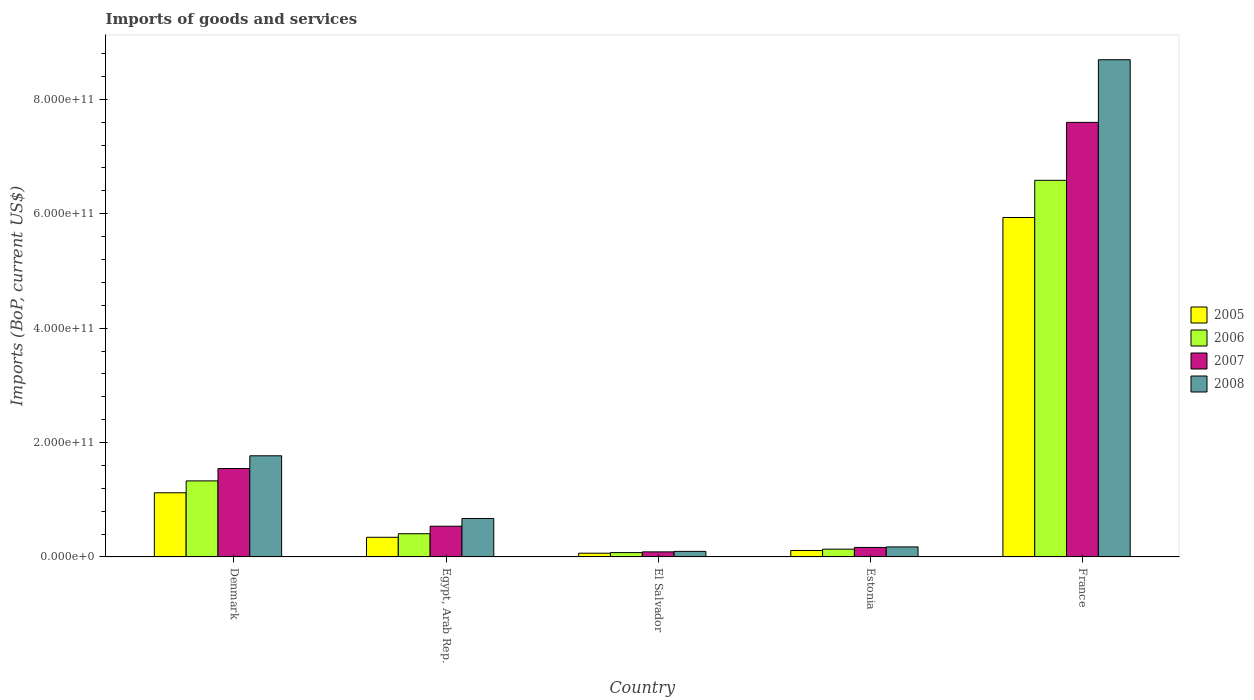How many groups of bars are there?
Keep it short and to the point. 5. Are the number of bars per tick equal to the number of legend labels?
Offer a very short reply. Yes. How many bars are there on the 4th tick from the left?
Provide a succinct answer. 4. How many bars are there on the 2nd tick from the right?
Your answer should be compact. 4. What is the label of the 3rd group of bars from the left?
Keep it short and to the point. El Salvador. In how many cases, is the number of bars for a given country not equal to the number of legend labels?
Offer a very short reply. 0. What is the amount spent on imports in 2005 in France?
Keep it short and to the point. 5.93e+11. Across all countries, what is the maximum amount spent on imports in 2006?
Provide a succinct answer. 6.58e+11. Across all countries, what is the minimum amount spent on imports in 2005?
Offer a terse response. 6.51e+09. In which country was the amount spent on imports in 2006 minimum?
Your answer should be very brief. El Salvador. What is the total amount spent on imports in 2007 in the graph?
Offer a terse response. 9.93e+11. What is the difference between the amount spent on imports in 2005 in Denmark and that in El Salvador?
Make the answer very short. 1.06e+11. What is the difference between the amount spent on imports in 2005 in El Salvador and the amount spent on imports in 2008 in Denmark?
Make the answer very short. -1.70e+11. What is the average amount spent on imports in 2005 per country?
Make the answer very short. 1.52e+11. What is the difference between the amount spent on imports of/in 2005 and amount spent on imports of/in 2006 in France?
Give a very brief answer. -6.50e+1. In how many countries, is the amount spent on imports in 2007 greater than 800000000000 US$?
Your answer should be compact. 0. What is the ratio of the amount spent on imports in 2007 in Denmark to that in France?
Offer a terse response. 0.2. Is the amount spent on imports in 2007 in Estonia less than that in France?
Ensure brevity in your answer.  Yes. Is the difference between the amount spent on imports in 2005 in Egypt, Arab Rep. and Estonia greater than the difference between the amount spent on imports in 2006 in Egypt, Arab Rep. and Estonia?
Offer a very short reply. No. What is the difference between the highest and the second highest amount spent on imports in 2006?
Your answer should be very brief. 5.26e+11. What is the difference between the highest and the lowest amount spent on imports in 2007?
Your response must be concise. 7.51e+11. In how many countries, is the amount spent on imports in 2006 greater than the average amount spent on imports in 2006 taken over all countries?
Provide a short and direct response. 1. What does the 4th bar from the left in France represents?
Offer a very short reply. 2008. What does the 3rd bar from the right in Estonia represents?
Keep it short and to the point. 2006. How many bars are there?
Your response must be concise. 20. Are all the bars in the graph horizontal?
Your response must be concise. No. What is the difference between two consecutive major ticks on the Y-axis?
Keep it short and to the point. 2.00e+11. Where does the legend appear in the graph?
Offer a very short reply. Center right. What is the title of the graph?
Give a very brief answer. Imports of goods and services. Does "2009" appear as one of the legend labels in the graph?
Keep it short and to the point. No. What is the label or title of the X-axis?
Your answer should be very brief. Country. What is the label or title of the Y-axis?
Offer a terse response. Imports (BoP, current US$). What is the Imports (BoP, current US$) in 2005 in Denmark?
Ensure brevity in your answer.  1.12e+11. What is the Imports (BoP, current US$) of 2006 in Denmark?
Your answer should be compact. 1.33e+11. What is the Imports (BoP, current US$) in 2007 in Denmark?
Provide a succinct answer. 1.55e+11. What is the Imports (BoP, current US$) in 2008 in Denmark?
Provide a short and direct response. 1.77e+11. What is the Imports (BoP, current US$) of 2005 in Egypt, Arab Rep.?
Offer a very short reply. 3.43e+1. What is the Imports (BoP, current US$) of 2006 in Egypt, Arab Rep.?
Offer a terse response. 4.06e+1. What is the Imports (BoP, current US$) of 2007 in Egypt, Arab Rep.?
Your response must be concise. 5.37e+1. What is the Imports (BoP, current US$) of 2008 in Egypt, Arab Rep.?
Give a very brief answer. 6.72e+1. What is the Imports (BoP, current US$) in 2005 in El Salvador?
Offer a terse response. 6.51e+09. What is the Imports (BoP, current US$) in 2006 in El Salvador?
Your response must be concise. 7.57e+09. What is the Imports (BoP, current US$) of 2007 in El Salvador?
Make the answer very short. 8.86e+09. What is the Imports (BoP, current US$) in 2008 in El Salvador?
Make the answer very short. 9.70e+09. What is the Imports (BoP, current US$) in 2005 in Estonia?
Offer a terse response. 1.12e+1. What is the Imports (BoP, current US$) in 2006 in Estonia?
Give a very brief answer. 1.36e+1. What is the Imports (BoP, current US$) in 2007 in Estonia?
Provide a short and direct response. 1.66e+1. What is the Imports (BoP, current US$) of 2008 in Estonia?
Ensure brevity in your answer.  1.75e+1. What is the Imports (BoP, current US$) in 2005 in France?
Your answer should be very brief. 5.93e+11. What is the Imports (BoP, current US$) in 2006 in France?
Your response must be concise. 6.58e+11. What is the Imports (BoP, current US$) in 2007 in France?
Your answer should be compact. 7.60e+11. What is the Imports (BoP, current US$) in 2008 in France?
Give a very brief answer. 8.69e+11. Across all countries, what is the maximum Imports (BoP, current US$) of 2005?
Your answer should be compact. 5.93e+11. Across all countries, what is the maximum Imports (BoP, current US$) of 2006?
Offer a terse response. 6.58e+11. Across all countries, what is the maximum Imports (BoP, current US$) in 2007?
Offer a very short reply. 7.60e+11. Across all countries, what is the maximum Imports (BoP, current US$) of 2008?
Offer a very short reply. 8.69e+11. Across all countries, what is the minimum Imports (BoP, current US$) of 2005?
Provide a short and direct response. 6.51e+09. Across all countries, what is the minimum Imports (BoP, current US$) in 2006?
Your answer should be very brief. 7.57e+09. Across all countries, what is the minimum Imports (BoP, current US$) of 2007?
Keep it short and to the point. 8.86e+09. Across all countries, what is the minimum Imports (BoP, current US$) in 2008?
Keep it short and to the point. 9.70e+09. What is the total Imports (BoP, current US$) of 2005 in the graph?
Make the answer very short. 7.58e+11. What is the total Imports (BoP, current US$) of 2006 in the graph?
Your answer should be very brief. 8.53e+11. What is the total Imports (BoP, current US$) of 2007 in the graph?
Provide a short and direct response. 9.93e+11. What is the total Imports (BoP, current US$) in 2008 in the graph?
Offer a terse response. 1.14e+12. What is the difference between the Imports (BoP, current US$) of 2005 in Denmark and that in Egypt, Arab Rep.?
Your response must be concise. 7.78e+1. What is the difference between the Imports (BoP, current US$) in 2006 in Denmark and that in Egypt, Arab Rep.?
Keep it short and to the point. 9.24e+1. What is the difference between the Imports (BoP, current US$) of 2007 in Denmark and that in Egypt, Arab Rep.?
Your answer should be very brief. 1.01e+11. What is the difference between the Imports (BoP, current US$) in 2008 in Denmark and that in Egypt, Arab Rep.?
Your answer should be compact. 1.10e+11. What is the difference between the Imports (BoP, current US$) in 2005 in Denmark and that in El Salvador?
Your response must be concise. 1.06e+11. What is the difference between the Imports (BoP, current US$) of 2006 in Denmark and that in El Salvador?
Provide a succinct answer. 1.25e+11. What is the difference between the Imports (BoP, current US$) of 2007 in Denmark and that in El Salvador?
Ensure brevity in your answer.  1.46e+11. What is the difference between the Imports (BoP, current US$) in 2008 in Denmark and that in El Salvador?
Offer a terse response. 1.67e+11. What is the difference between the Imports (BoP, current US$) of 2005 in Denmark and that in Estonia?
Provide a short and direct response. 1.01e+11. What is the difference between the Imports (BoP, current US$) of 2006 in Denmark and that in Estonia?
Offer a terse response. 1.19e+11. What is the difference between the Imports (BoP, current US$) of 2007 in Denmark and that in Estonia?
Give a very brief answer. 1.38e+11. What is the difference between the Imports (BoP, current US$) in 2008 in Denmark and that in Estonia?
Your response must be concise. 1.59e+11. What is the difference between the Imports (BoP, current US$) of 2005 in Denmark and that in France?
Offer a terse response. -4.81e+11. What is the difference between the Imports (BoP, current US$) of 2006 in Denmark and that in France?
Make the answer very short. -5.26e+11. What is the difference between the Imports (BoP, current US$) in 2007 in Denmark and that in France?
Offer a very short reply. -6.05e+11. What is the difference between the Imports (BoP, current US$) of 2008 in Denmark and that in France?
Give a very brief answer. -6.92e+11. What is the difference between the Imports (BoP, current US$) of 2005 in Egypt, Arab Rep. and that in El Salvador?
Provide a succinct answer. 2.78e+1. What is the difference between the Imports (BoP, current US$) of 2006 in Egypt, Arab Rep. and that in El Salvador?
Provide a short and direct response. 3.30e+1. What is the difference between the Imports (BoP, current US$) in 2007 in Egypt, Arab Rep. and that in El Salvador?
Give a very brief answer. 4.48e+1. What is the difference between the Imports (BoP, current US$) in 2008 in Egypt, Arab Rep. and that in El Salvador?
Give a very brief answer. 5.75e+1. What is the difference between the Imports (BoP, current US$) of 2005 in Egypt, Arab Rep. and that in Estonia?
Your answer should be very brief. 2.31e+1. What is the difference between the Imports (BoP, current US$) in 2006 in Egypt, Arab Rep. and that in Estonia?
Provide a short and direct response. 2.69e+1. What is the difference between the Imports (BoP, current US$) of 2007 in Egypt, Arab Rep. and that in Estonia?
Offer a terse response. 3.71e+1. What is the difference between the Imports (BoP, current US$) of 2008 in Egypt, Arab Rep. and that in Estonia?
Your answer should be compact. 4.97e+1. What is the difference between the Imports (BoP, current US$) in 2005 in Egypt, Arab Rep. and that in France?
Your response must be concise. -5.59e+11. What is the difference between the Imports (BoP, current US$) of 2006 in Egypt, Arab Rep. and that in France?
Your answer should be very brief. -6.18e+11. What is the difference between the Imports (BoP, current US$) in 2007 in Egypt, Arab Rep. and that in France?
Keep it short and to the point. -7.06e+11. What is the difference between the Imports (BoP, current US$) of 2008 in Egypt, Arab Rep. and that in France?
Offer a very short reply. -8.02e+11. What is the difference between the Imports (BoP, current US$) of 2005 in El Salvador and that in Estonia?
Ensure brevity in your answer.  -4.74e+09. What is the difference between the Imports (BoP, current US$) in 2006 in El Salvador and that in Estonia?
Keep it short and to the point. -6.05e+09. What is the difference between the Imports (BoP, current US$) of 2007 in El Salvador and that in Estonia?
Give a very brief answer. -7.72e+09. What is the difference between the Imports (BoP, current US$) in 2008 in El Salvador and that in Estonia?
Give a very brief answer. -7.81e+09. What is the difference between the Imports (BoP, current US$) in 2005 in El Salvador and that in France?
Give a very brief answer. -5.87e+11. What is the difference between the Imports (BoP, current US$) in 2006 in El Salvador and that in France?
Make the answer very short. -6.51e+11. What is the difference between the Imports (BoP, current US$) in 2007 in El Salvador and that in France?
Keep it short and to the point. -7.51e+11. What is the difference between the Imports (BoP, current US$) in 2008 in El Salvador and that in France?
Give a very brief answer. -8.60e+11. What is the difference between the Imports (BoP, current US$) of 2005 in Estonia and that in France?
Provide a succinct answer. -5.82e+11. What is the difference between the Imports (BoP, current US$) of 2006 in Estonia and that in France?
Offer a terse response. -6.45e+11. What is the difference between the Imports (BoP, current US$) in 2007 in Estonia and that in France?
Make the answer very short. -7.43e+11. What is the difference between the Imports (BoP, current US$) in 2008 in Estonia and that in France?
Provide a short and direct response. -8.52e+11. What is the difference between the Imports (BoP, current US$) of 2005 in Denmark and the Imports (BoP, current US$) of 2006 in Egypt, Arab Rep.?
Your answer should be compact. 7.16e+1. What is the difference between the Imports (BoP, current US$) of 2005 in Denmark and the Imports (BoP, current US$) of 2007 in Egypt, Arab Rep.?
Your answer should be compact. 5.85e+1. What is the difference between the Imports (BoP, current US$) of 2005 in Denmark and the Imports (BoP, current US$) of 2008 in Egypt, Arab Rep.?
Give a very brief answer. 4.49e+1. What is the difference between the Imports (BoP, current US$) in 2006 in Denmark and the Imports (BoP, current US$) in 2007 in Egypt, Arab Rep.?
Offer a very short reply. 7.92e+1. What is the difference between the Imports (BoP, current US$) of 2006 in Denmark and the Imports (BoP, current US$) of 2008 in Egypt, Arab Rep.?
Give a very brief answer. 6.57e+1. What is the difference between the Imports (BoP, current US$) in 2007 in Denmark and the Imports (BoP, current US$) in 2008 in Egypt, Arab Rep.?
Offer a very short reply. 8.74e+1. What is the difference between the Imports (BoP, current US$) in 2005 in Denmark and the Imports (BoP, current US$) in 2006 in El Salvador?
Your answer should be very brief. 1.05e+11. What is the difference between the Imports (BoP, current US$) in 2005 in Denmark and the Imports (BoP, current US$) in 2007 in El Salvador?
Provide a short and direct response. 1.03e+11. What is the difference between the Imports (BoP, current US$) of 2005 in Denmark and the Imports (BoP, current US$) of 2008 in El Salvador?
Give a very brief answer. 1.02e+11. What is the difference between the Imports (BoP, current US$) in 2006 in Denmark and the Imports (BoP, current US$) in 2007 in El Salvador?
Offer a very short reply. 1.24e+11. What is the difference between the Imports (BoP, current US$) in 2006 in Denmark and the Imports (BoP, current US$) in 2008 in El Salvador?
Keep it short and to the point. 1.23e+11. What is the difference between the Imports (BoP, current US$) of 2007 in Denmark and the Imports (BoP, current US$) of 2008 in El Salvador?
Keep it short and to the point. 1.45e+11. What is the difference between the Imports (BoP, current US$) of 2005 in Denmark and the Imports (BoP, current US$) of 2006 in Estonia?
Offer a terse response. 9.85e+1. What is the difference between the Imports (BoP, current US$) in 2005 in Denmark and the Imports (BoP, current US$) in 2007 in Estonia?
Your response must be concise. 9.56e+1. What is the difference between the Imports (BoP, current US$) of 2005 in Denmark and the Imports (BoP, current US$) of 2008 in Estonia?
Your answer should be compact. 9.46e+1. What is the difference between the Imports (BoP, current US$) in 2006 in Denmark and the Imports (BoP, current US$) in 2007 in Estonia?
Your answer should be very brief. 1.16e+11. What is the difference between the Imports (BoP, current US$) of 2006 in Denmark and the Imports (BoP, current US$) of 2008 in Estonia?
Offer a very short reply. 1.15e+11. What is the difference between the Imports (BoP, current US$) of 2007 in Denmark and the Imports (BoP, current US$) of 2008 in Estonia?
Your answer should be compact. 1.37e+11. What is the difference between the Imports (BoP, current US$) in 2005 in Denmark and the Imports (BoP, current US$) in 2006 in France?
Ensure brevity in your answer.  -5.46e+11. What is the difference between the Imports (BoP, current US$) in 2005 in Denmark and the Imports (BoP, current US$) in 2007 in France?
Keep it short and to the point. -6.48e+11. What is the difference between the Imports (BoP, current US$) in 2005 in Denmark and the Imports (BoP, current US$) in 2008 in France?
Your response must be concise. -7.57e+11. What is the difference between the Imports (BoP, current US$) in 2006 in Denmark and the Imports (BoP, current US$) in 2007 in France?
Ensure brevity in your answer.  -6.27e+11. What is the difference between the Imports (BoP, current US$) of 2006 in Denmark and the Imports (BoP, current US$) of 2008 in France?
Provide a succinct answer. -7.36e+11. What is the difference between the Imports (BoP, current US$) in 2007 in Denmark and the Imports (BoP, current US$) in 2008 in France?
Ensure brevity in your answer.  -7.15e+11. What is the difference between the Imports (BoP, current US$) in 2005 in Egypt, Arab Rep. and the Imports (BoP, current US$) in 2006 in El Salvador?
Offer a very short reply. 2.68e+1. What is the difference between the Imports (BoP, current US$) in 2005 in Egypt, Arab Rep. and the Imports (BoP, current US$) in 2007 in El Salvador?
Offer a very short reply. 2.55e+1. What is the difference between the Imports (BoP, current US$) of 2005 in Egypt, Arab Rep. and the Imports (BoP, current US$) of 2008 in El Salvador?
Offer a terse response. 2.46e+1. What is the difference between the Imports (BoP, current US$) in 2006 in Egypt, Arab Rep. and the Imports (BoP, current US$) in 2007 in El Salvador?
Your answer should be very brief. 3.17e+1. What is the difference between the Imports (BoP, current US$) of 2006 in Egypt, Arab Rep. and the Imports (BoP, current US$) of 2008 in El Salvador?
Your answer should be very brief. 3.09e+1. What is the difference between the Imports (BoP, current US$) of 2007 in Egypt, Arab Rep. and the Imports (BoP, current US$) of 2008 in El Salvador?
Give a very brief answer. 4.40e+1. What is the difference between the Imports (BoP, current US$) in 2005 in Egypt, Arab Rep. and the Imports (BoP, current US$) in 2006 in Estonia?
Your response must be concise. 2.07e+1. What is the difference between the Imports (BoP, current US$) of 2005 in Egypt, Arab Rep. and the Imports (BoP, current US$) of 2007 in Estonia?
Provide a short and direct response. 1.78e+1. What is the difference between the Imports (BoP, current US$) of 2005 in Egypt, Arab Rep. and the Imports (BoP, current US$) of 2008 in Estonia?
Provide a succinct answer. 1.68e+1. What is the difference between the Imports (BoP, current US$) in 2006 in Egypt, Arab Rep. and the Imports (BoP, current US$) in 2007 in Estonia?
Your response must be concise. 2.40e+1. What is the difference between the Imports (BoP, current US$) in 2006 in Egypt, Arab Rep. and the Imports (BoP, current US$) in 2008 in Estonia?
Your answer should be compact. 2.30e+1. What is the difference between the Imports (BoP, current US$) in 2007 in Egypt, Arab Rep. and the Imports (BoP, current US$) in 2008 in Estonia?
Offer a terse response. 3.62e+1. What is the difference between the Imports (BoP, current US$) of 2005 in Egypt, Arab Rep. and the Imports (BoP, current US$) of 2006 in France?
Your response must be concise. -6.24e+11. What is the difference between the Imports (BoP, current US$) of 2005 in Egypt, Arab Rep. and the Imports (BoP, current US$) of 2007 in France?
Keep it short and to the point. -7.25e+11. What is the difference between the Imports (BoP, current US$) of 2005 in Egypt, Arab Rep. and the Imports (BoP, current US$) of 2008 in France?
Provide a short and direct response. -8.35e+11. What is the difference between the Imports (BoP, current US$) of 2006 in Egypt, Arab Rep. and the Imports (BoP, current US$) of 2007 in France?
Your answer should be very brief. -7.19e+11. What is the difference between the Imports (BoP, current US$) in 2006 in Egypt, Arab Rep. and the Imports (BoP, current US$) in 2008 in France?
Offer a terse response. -8.29e+11. What is the difference between the Imports (BoP, current US$) in 2007 in Egypt, Arab Rep. and the Imports (BoP, current US$) in 2008 in France?
Ensure brevity in your answer.  -8.16e+11. What is the difference between the Imports (BoP, current US$) of 2005 in El Salvador and the Imports (BoP, current US$) of 2006 in Estonia?
Your answer should be very brief. -7.11e+09. What is the difference between the Imports (BoP, current US$) in 2005 in El Salvador and the Imports (BoP, current US$) in 2007 in Estonia?
Provide a succinct answer. -1.01e+1. What is the difference between the Imports (BoP, current US$) of 2005 in El Salvador and the Imports (BoP, current US$) of 2008 in Estonia?
Make the answer very short. -1.10e+1. What is the difference between the Imports (BoP, current US$) in 2006 in El Salvador and the Imports (BoP, current US$) in 2007 in Estonia?
Ensure brevity in your answer.  -9.00e+09. What is the difference between the Imports (BoP, current US$) in 2006 in El Salvador and the Imports (BoP, current US$) in 2008 in Estonia?
Offer a terse response. -9.94e+09. What is the difference between the Imports (BoP, current US$) of 2007 in El Salvador and the Imports (BoP, current US$) of 2008 in Estonia?
Make the answer very short. -8.66e+09. What is the difference between the Imports (BoP, current US$) of 2005 in El Salvador and the Imports (BoP, current US$) of 2006 in France?
Make the answer very short. -6.52e+11. What is the difference between the Imports (BoP, current US$) of 2005 in El Salvador and the Imports (BoP, current US$) of 2007 in France?
Offer a very short reply. -7.53e+11. What is the difference between the Imports (BoP, current US$) in 2005 in El Salvador and the Imports (BoP, current US$) in 2008 in France?
Your response must be concise. -8.63e+11. What is the difference between the Imports (BoP, current US$) of 2006 in El Salvador and the Imports (BoP, current US$) of 2007 in France?
Provide a short and direct response. -7.52e+11. What is the difference between the Imports (BoP, current US$) in 2006 in El Salvador and the Imports (BoP, current US$) in 2008 in France?
Offer a terse response. -8.62e+11. What is the difference between the Imports (BoP, current US$) in 2007 in El Salvador and the Imports (BoP, current US$) in 2008 in France?
Make the answer very short. -8.60e+11. What is the difference between the Imports (BoP, current US$) in 2005 in Estonia and the Imports (BoP, current US$) in 2006 in France?
Make the answer very short. -6.47e+11. What is the difference between the Imports (BoP, current US$) in 2005 in Estonia and the Imports (BoP, current US$) in 2007 in France?
Your response must be concise. -7.48e+11. What is the difference between the Imports (BoP, current US$) in 2005 in Estonia and the Imports (BoP, current US$) in 2008 in France?
Provide a short and direct response. -8.58e+11. What is the difference between the Imports (BoP, current US$) of 2006 in Estonia and the Imports (BoP, current US$) of 2007 in France?
Provide a short and direct response. -7.46e+11. What is the difference between the Imports (BoP, current US$) of 2006 in Estonia and the Imports (BoP, current US$) of 2008 in France?
Offer a very short reply. -8.56e+11. What is the difference between the Imports (BoP, current US$) in 2007 in Estonia and the Imports (BoP, current US$) in 2008 in France?
Your response must be concise. -8.53e+11. What is the average Imports (BoP, current US$) of 2005 per country?
Ensure brevity in your answer.  1.52e+11. What is the average Imports (BoP, current US$) in 2006 per country?
Make the answer very short. 1.71e+11. What is the average Imports (BoP, current US$) of 2007 per country?
Provide a succinct answer. 1.99e+11. What is the average Imports (BoP, current US$) in 2008 per country?
Your answer should be very brief. 2.28e+11. What is the difference between the Imports (BoP, current US$) in 2005 and Imports (BoP, current US$) in 2006 in Denmark?
Give a very brief answer. -2.08e+1. What is the difference between the Imports (BoP, current US$) in 2005 and Imports (BoP, current US$) in 2007 in Denmark?
Your answer should be very brief. -4.24e+1. What is the difference between the Imports (BoP, current US$) of 2005 and Imports (BoP, current US$) of 2008 in Denmark?
Offer a terse response. -6.47e+1. What is the difference between the Imports (BoP, current US$) in 2006 and Imports (BoP, current US$) in 2007 in Denmark?
Provide a succinct answer. -2.17e+1. What is the difference between the Imports (BoP, current US$) of 2006 and Imports (BoP, current US$) of 2008 in Denmark?
Provide a short and direct response. -4.39e+1. What is the difference between the Imports (BoP, current US$) of 2007 and Imports (BoP, current US$) of 2008 in Denmark?
Make the answer very short. -2.22e+1. What is the difference between the Imports (BoP, current US$) in 2005 and Imports (BoP, current US$) in 2006 in Egypt, Arab Rep.?
Your answer should be very brief. -6.23e+09. What is the difference between the Imports (BoP, current US$) in 2005 and Imports (BoP, current US$) in 2007 in Egypt, Arab Rep.?
Make the answer very short. -1.94e+1. What is the difference between the Imports (BoP, current US$) in 2005 and Imports (BoP, current US$) in 2008 in Egypt, Arab Rep.?
Make the answer very short. -3.29e+1. What is the difference between the Imports (BoP, current US$) in 2006 and Imports (BoP, current US$) in 2007 in Egypt, Arab Rep.?
Your answer should be compact. -1.31e+1. What is the difference between the Imports (BoP, current US$) in 2006 and Imports (BoP, current US$) in 2008 in Egypt, Arab Rep.?
Your answer should be compact. -2.67e+1. What is the difference between the Imports (BoP, current US$) of 2007 and Imports (BoP, current US$) of 2008 in Egypt, Arab Rep.?
Your answer should be compact. -1.35e+1. What is the difference between the Imports (BoP, current US$) in 2005 and Imports (BoP, current US$) in 2006 in El Salvador?
Provide a succinct answer. -1.06e+09. What is the difference between the Imports (BoP, current US$) in 2005 and Imports (BoP, current US$) in 2007 in El Salvador?
Make the answer very short. -2.35e+09. What is the difference between the Imports (BoP, current US$) of 2005 and Imports (BoP, current US$) of 2008 in El Salvador?
Your answer should be very brief. -3.19e+09. What is the difference between the Imports (BoP, current US$) in 2006 and Imports (BoP, current US$) in 2007 in El Salvador?
Provide a succinct answer. -1.28e+09. What is the difference between the Imports (BoP, current US$) of 2006 and Imports (BoP, current US$) of 2008 in El Salvador?
Provide a short and direct response. -2.13e+09. What is the difference between the Imports (BoP, current US$) in 2007 and Imports (BoP, current US$) in 2008 in El Salvador?
Your answer should be compact. -8.44e+08. What is the difference between the Imports (BoP, current US$) in 2005 and Imports (BoP, current US$) in 2006 in Estonia?
Make the answer very short. -2.37e+09. What is the difference between the Imports (BoP, current US$) in 2005 and Imports (BoP, current US$) in 2007 in Estonia?
Make the answer very short. -5.32e+09. What is the difference between the Imports (BoP, current US$) in 2005 and Imports (BoP, current US$) in 2008 in Estonia?
Provide a succinct answer. -6.27e+09. What is the difference between the Imports (BoP, current US$) in 2006 and Imports (BoP, current US$) in 2007 in Estonia?
Offer a terse response. -2.95e+09. What is the difference between the Imports (BoP, current US$) in 2006 and Imports (BoP, current US$) in 2008 in Estonia?
Offer a terse response. -3.90e+09. What is the difference between the Imports (BoP, current US$) in 2007 and Imports (BoP, current US$) in 2008 in Estonia?
Your answer should be very brief. -9.43e+08. What is the difference between the Imports (BoP, current US$) of 2005 and Imports (BoP, current US$) of 2006 in France?
Your response must be concise. -6.50e+1. What is the difference between the Imports (BoP, current US$) in 2005 and Imports (BoP, current US$) in 2007 in France?
Your response must be concise. -1.66e+11. What is the difference between the Imports (BoP, current US$) of 2005 and Imports (BoP, current US$) of 2008 in France?
Offer a very short reply. -2.76e+11. What is the difference between the Imports (BoP, current US$) in 2006 and Imports (BoP, current US$) in 2007 in France?
Ensure brevity in your answer.  -1.01e+11. What is the difference between the Imports (BoP, current US$) of 2006 and Imports (BoP, current US$) of 2008 in France?
Offer a very short reply. -2.11e+11. What is the difference between the Imports (BoP, current US$) in 2007 and Imports (BoP, current US$) in 2008 in France?
Offer a very short reply. -1.09e+11. What is the ratio of the Imports (BoP, current US$) in 2005 in Denmark to that in Egypt, Arab Rep.?
Provide a succinct answer. 3.27. What is the ratio of the Imports (BoP, current US$) of 2006 in Denmark to that in Egypt, Arab Rep.?
Ensure brevity in your answer.  3.28. What is the ratio of the Imports (BoP, current US$) in 2007 in Denmark to that in Egypt, Arab Rep.?
Offer a terse response. 2.88. What is the ratio of the Imports (BoP, current US$) in 2008 in Denmark to that in Egypt, Arab Rep.?
Provide a succinct answer. 2.63. What is the ratio of the Imports (BoP, current US$) of 2005 in Denmark to that in El Salvador?
Give a very brief answer. 17.23. What is the ratio of the Imports (BoP, current US$) in 2006 in Denmark to that in El Salvador?
Your answer should be very brief. 17.56. What is the ratio of the Imports (BoP, current US$) of 2007 in Denmark to that in El Salvador?
Make the answer very short. 17.46. What is the ratio of the Imports (BoP, current US$) of 2008 in Denmark to that in El Salvador?
Ensure brevity in your answer.  18.23. What is the ratio of the Imports (BoP, current US$) of 2005 in Denmark to that in Estonia?
Offer a very short reply. 9.97. What is the ratio of the Imports (BoP, current US$) of 2006 in Denmark to that in Estonia?
Your answer should be compact. 9.76. What is the ratio of the Imports (BoP, current US$) in 2007 in Denmark to that in Estonia?
Your answer should be compact. 9.33. What is the ratio of the Imports (BoP, current US$) in 2008 in Denmark to that in Estonia?
Offer a very short reply. 10.1. What is the ratio of the Imports (BoP, current US$) of 2005 in Denmark to that in France?
Offer a very short reply. 0.19. What is the ratio of the Imports (BoP, current US$) in 2006 in Denmark to that in France?
Ensure brevity in your answer.  0.2. What is the ratio of the Imports (BoP, current US$) of 2007 in Denmark to that in France?
Give a very brief answer. 0.2. What is the ratio of the Imports (BoP, current US$) in 2008 in Denmark to that in France?
Ensure brevity in your answer.  0.2. What is the ratio of the Imports (BoP, current US$) of 2005 in Egypt, Arab Rep. to that in El Salvador?
Your answer should be compact. 5.27. What is the ratio of the Imports (BoP, current US$) of 2006 in Egypt, Arab Rep. to that in El Salvador?
Your answer should be compact. 5.36. What is the ratio of the Imports (BoP, current US$) of 2007 in Egypt, Arab Rep. to that in El Salvador?
Make the answer very short. 6.06. What is the ratio of the Imports (BoP, current US$) in 2008 in Egypt, Arab Rep. to that in El Salvador?
Your answer should be compact. 6.93. What is the ratio of the Imports (BoP, current US$) in 2005 in Egypt, Arab Rep. to that in Estonia?
Ensure brevity in your answer.  3.05. What is the ratio of the Imports (BoP, current US$) in 2006 in Egypt, Arab Rep. to that in Estonia?
Ensure brevity in your answer.  2.98. What is the ratio of the Imports (BoP, current US$) in 2007 in Egypt, Arab Rep. to that in Estonia?
Provide a succinct answer. 3.24. What is the ratio of the Imports (BoP, current US$) of 2008 in Egypt, Arab Rep. to that in Estonia?
Ensure brevity in your answer.  3.84. What is the ratio of the Imports (BoP, current US$) of 2005 in Egypt, Arab Rep. to that in France?
Ensure brevity in your answer.  0.06. What is the ratio of the Imports (BoP, current US$) in 2006 in Egypt, Arab Rep. to that in France?
Provide a succinct answer. 0.06. What is the ratio of the Imports (BoP, current US$) in 2007 in Egypt, Arab Rep. to that in France?
Offer a terse response. 0.07. What is the ratio of the Imports (BoP, current US$) of 2008 in Egypt, Arab Rep. to that in France?
Offer a terse response. 0.08. What is the ratio of the Imports (BoP, current US$) in 2005 in El Salvador to that in Estonia?
Provide a short and direct response. 0.58. What is the ratio of the Imports (BoP, current US$) in 2006 in El Salvador to that in Estonia?
Offer a terse response. 0.56. What is the ratio of the Imports (BoP, current US$) of 2007 in El Salvador to that in Estonia?
Provide a short and direct response. 0.53. What is the ratio of the Imports (BoP, current US$) in 2008 in El Salvador to that in Estonia?
Provide a short and direct response. 0.55. What is the ratio of the Imports (BoP, current US$) in 2005 in El Salvador to that in France?
Keep it short and to the point. 0.01. What is the ratio of the Imports (BoP, current US$) of 2006 in El Salvador to that in France?
Offer a very short reply. 0.01. What is the ratio of the Imports (BoP, current US$) in 2007 in El Salvador to that in France?
Your answer should be very brief. 0.01. What is the ratio of the Imports (BoP, current US$) of 2008 in El Salvador to that in France?
Make the answer very short. 0.01. What is the ratio of the Imports (BoP, current US$) of 2005 in Estonia to that in France?
Your answer should be very brief. 0.02. What is the ratio of the Imports (BoP, current US$) in 2006 in Estonia to that in France?
Ensure brevity in your answer.  0.02. What is the ratio of the Imports (BoP, current US$) of 2007 in Estonia to that in France?
Provide a succinct answer. 0.02. What is the ratio of the Imports (BoP, current US$) of 2008 in Estonia to that in France?
Offer a terse response. 0.02. What is the difference between the highest and the second highest Imports (BoP, current US$) in 2005?
Your answer should be compact. 4.81e+11. What is the difference between the highest and the second highest Imports (BoP, current US$) of 2006?
Offer a very short reply. 5.26e+11. What is the difference between the highest and the second highest Imports (BoP, current US$) in 2007?
Provide a succinct answer. 6.05e+11. What is the difference between the highest and the second highest Imports (BoP, current US$) in 2008?
Provide a short and direct response. 6.92e+11. What is the difference between the highest and the lowest Imports (BoP, current US$) of 2005?
Your response must be concise. 5.87e+11. What is the difference between the highest and the lowest Imports (BoP, current US$) in 2006?
Provide a short and direct response. 6.51e+11. What is the difference between the highest and the lowest Imports (BoP, current US$) of 2007?
Offer a very short reply. 7.51e+11. What is the difference between the highest and the lowest Imports (BoP, current US$) of 2008?
Keep it short and to the point. 8.60e+11. 